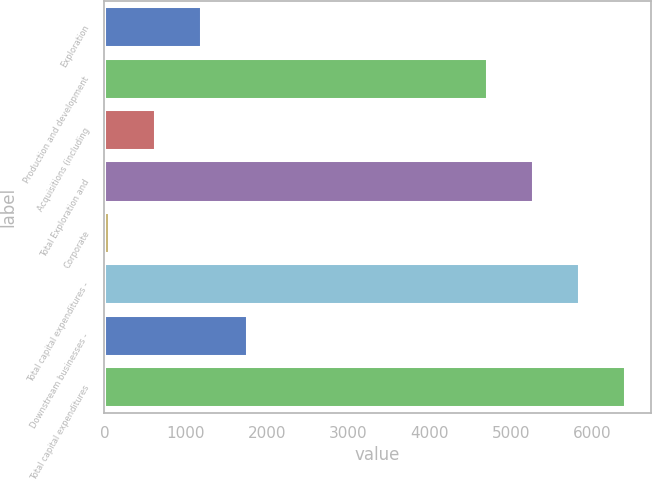Convert chart. <chart><loc_0><loc_0><loc_500><loc_500><bar_chart><fcel>Exploration<fcel>Production and development<fcel>Acquisitions (including<fcel>Total Exploration and<fcel>Corporate<fcel>Total capital expenditures -<fcel>Downstream businesses -<fcel>Total capital expenditures<nl><fcel>1183.4<fcel>4702<fcel>618.2<fcel>5267.2<fcel>53<fcel>5832.4<fcel>1748.6<fcel>6397.6<nl></chart> 